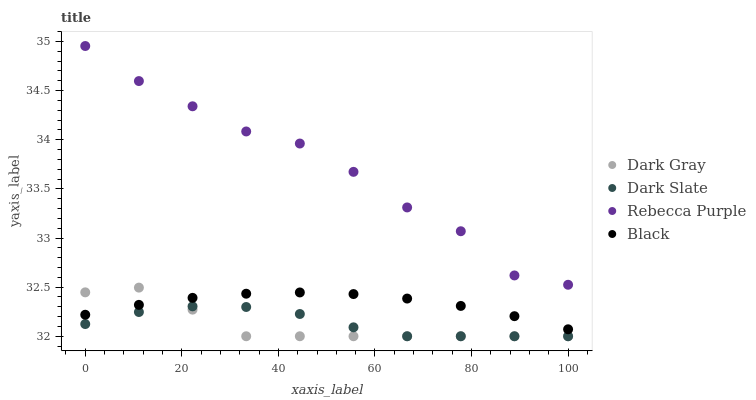Does Dark Gray have the minimum area under the curve?
Answer yes or no. Yes. Does Rebecca Purple have the maximum area under the curve?
Answer yes or no. Yes. Does Dark Slate have the minimum area under the curve?
Answer yes or no. No. Does Dark Slate have the maximum area under the curve?
Answer yes or no. No. Is Black the smoothest?
Answer yes or no. Yes. Is Rebecca Purple the roughest?
Answer yes or no. Yes. Is Dark Slate the smoothest?
Answer yes or no. No. Is Dark Slate the roughest?
Answer yes or no. No. Does Dark Gray have the lowest value?
Answer yes or no. Yes. Does Black have the lowest value?
Answer yes or no. No. Does Rebecca Purple have the highest value?
Answer yes or no. Yes. Does Black have the highest value?
Answer yes or no. No. Is Black less than Rebecca Purple?
Answer yes or no. Yes. Is Black greater than Dark Slate?
Answer yes or no. Yes. Does Dark Gray intersect Black?
Answer yes or no. Yes. Is Dark Gray less than Black?
Answer yes or no. No. Is Dark Gray greater than Black?
Answer yes or no. No. Does Black intersect Rebecca Purple?
Answer yes or no. No. 